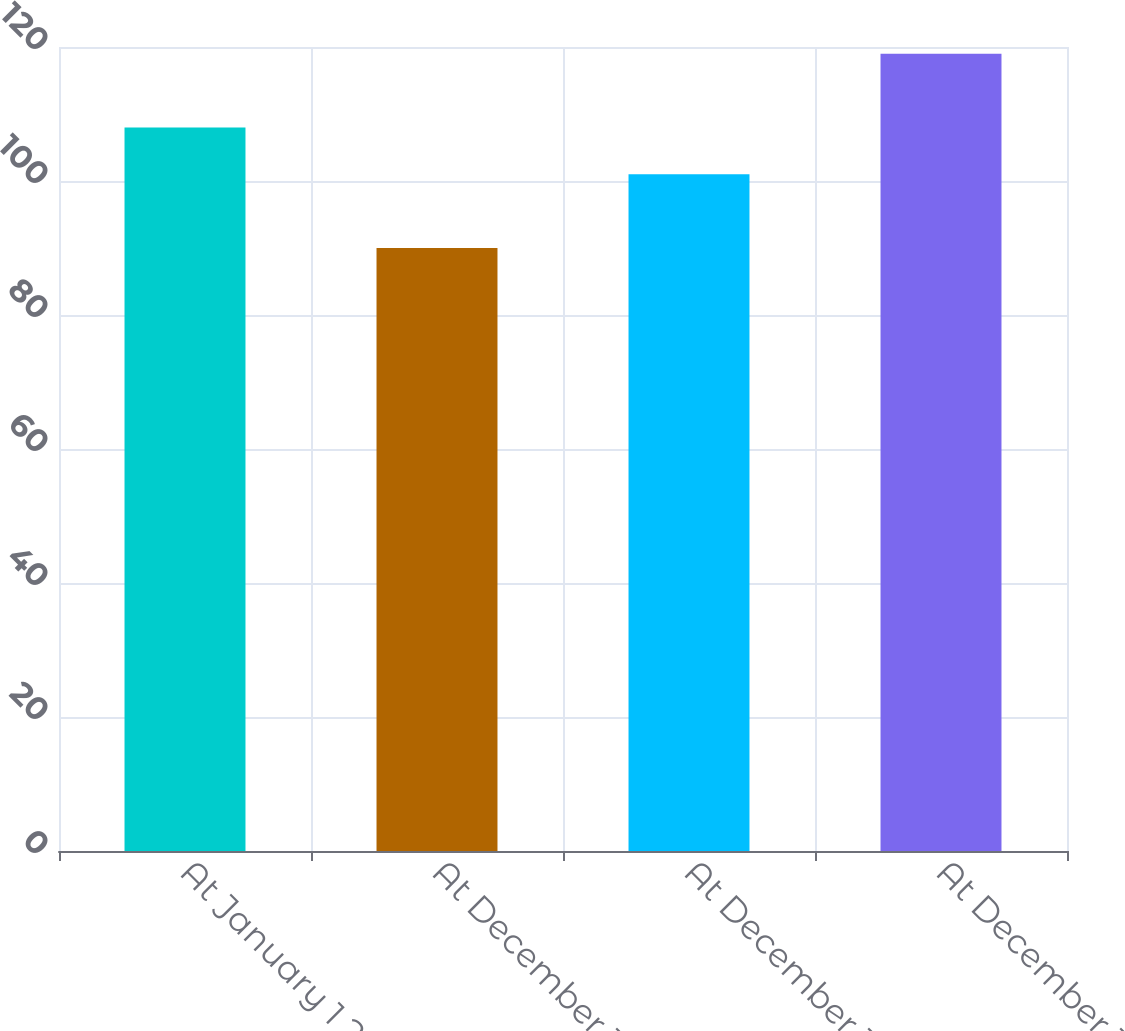<chart> <loc_0><loc_0><loc_500><loc_500><bar_chart><fcel>At January 1 2006<fcel>At December 31 2006<fcel>At December 31 2007<fcel>At December 31 2008<nl><fcel>108<fcel>90<fcel>101<fcel>119<nl></chart> 